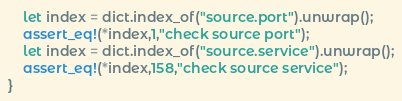Convert code to text. <code><loc_0><loc_0><loc_500><loc_500><_Rust_>    let index = dict.index_of("source.port").unwrap();
    assert_eq!(*index,1,"check source port");
    let index = dict.index_of("source.service").unwrap();
    assert_eq!(*index,158,"check source service");
}
</code> 